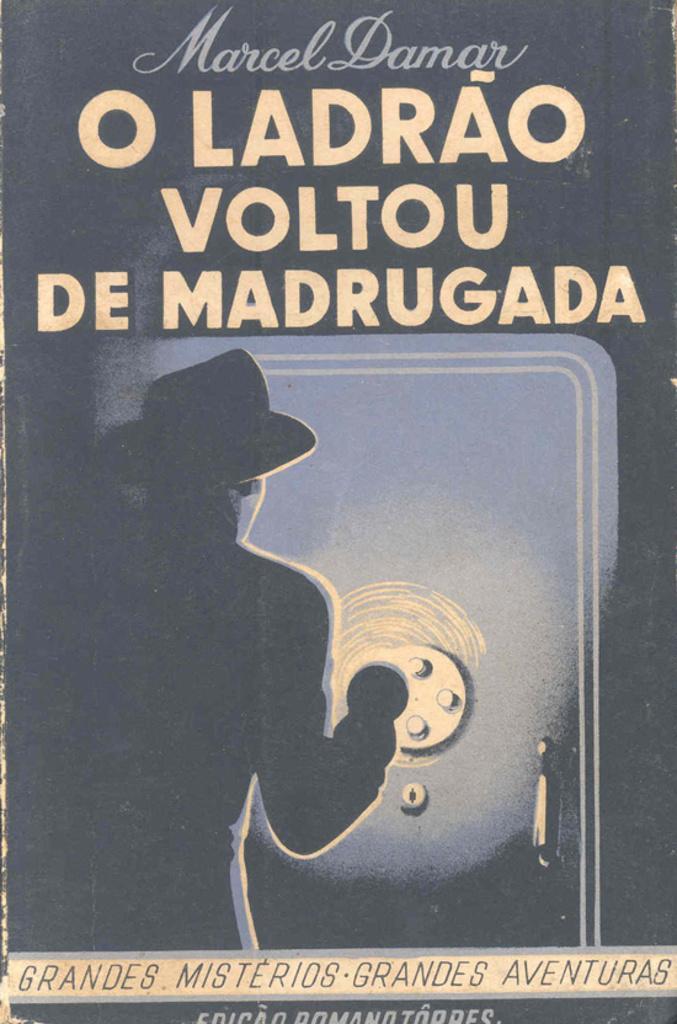Can you describe this image briefly? In this image we can see the cover page of a book in which there is a person wearing hat standing near the door and we can see words. 